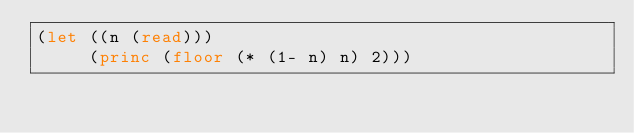Convert code to text. <code><loc_0><loc_0><loc_500><loc_500><_Lisp_>(let ((n (read)))
     (princ (floor (* (1- n) n) 2)))</code> 